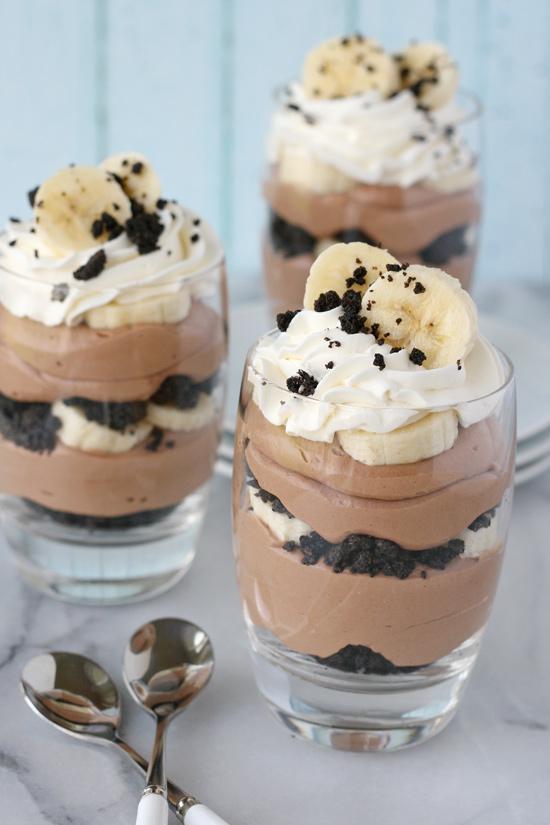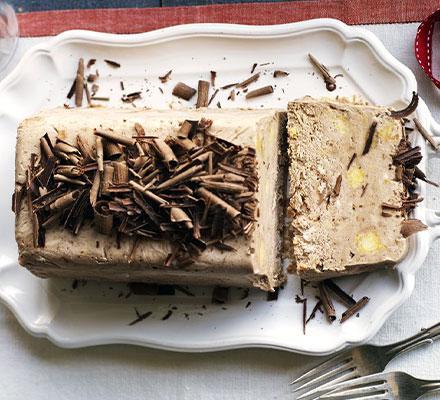The first image is the image on the left, the second image is the image on the right. Examine the images to the left and right. Is the description "An image shows a layered dessert in a footed glass, with a topping that includes sliced strawberries." accurate? Answer yes or no. No. 